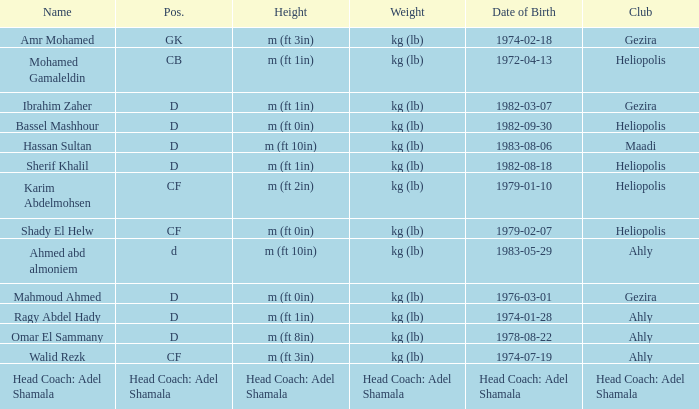What is Weight, when Club is "Maadi"? Kg (lb). Write the full table. {'header': ['Name', 'Pos.', 'Height', 'Weight', 'Date of Birth', 'Club'], 'rows': [['Amr Mohamed', 'GK', 'm (ft 3in)', 'kg (lb)', '1974-02-18', 'Gezira'], ['Mohamed Gamaleldin', 'CB', 'm (ft 1in)', 'kg (lb)', '1972-04-13', 'Heliopolis'], ['Ibrahim Zaher', 'D', 'm (ft 1in)', 'kg (lb)', '1982-03-07', 'Gezira'], ['Bassel Mashhour', 'D', 'm (ft 0in)', 'kg (lb)', '1982-09-30', 'Heliopolis'], ['Hassan Sultan', 'D', 'm (ft 10in)', 'kg (lb)', '1983-08-06', 'Maadi'], ['Sherif Khalil', 'D', 'm (ft 1in)', 'kg (lb)', '1982-08-18', 'Heliopolis'], ['Karim Abdelmohsen', 'CF', 'm (ft 2in)', 'kg (lb)', '1979-01-10', 'Heliopolis'], ['Shady El Helw', 'CF', 'm (ft 0in)', 'kg (lb)', '1979-02-07', 'Heliopolis'], ['Ahmed abd almoniem', 'd', 'm (ft 10in)', 'kg (lb)', '1983-05-29', 'Ahly'], ['Mahmoud Ahmed', 'D', 'm (ft 0in)', 'kg (lb)', '1976-03-01', 'Gezira'], ['Ragy Abdel Hady', 'D', 'm (ft 1in)', 'kg (lb)', '1974-01-28', 'Ahly'], ['Omar El Sammany', 'D', 'm (ft 8in)', 'kg (lb)', '1978-08-22', 'Ahly'], ['Walid Rezk', 'CF', 'm (ft 3in)', 'kg (lb)', '1974-07-19', 'Ahly'], ['Head Coach: Adel Shamala', 'Head Coach: Adel Shamala', 'Head Coach: Adel Shamala', 'Head Coach: Adel Shamala', 'Head Coach: Adel Shamala', 'Head Coach: Adel Shamala']]} 